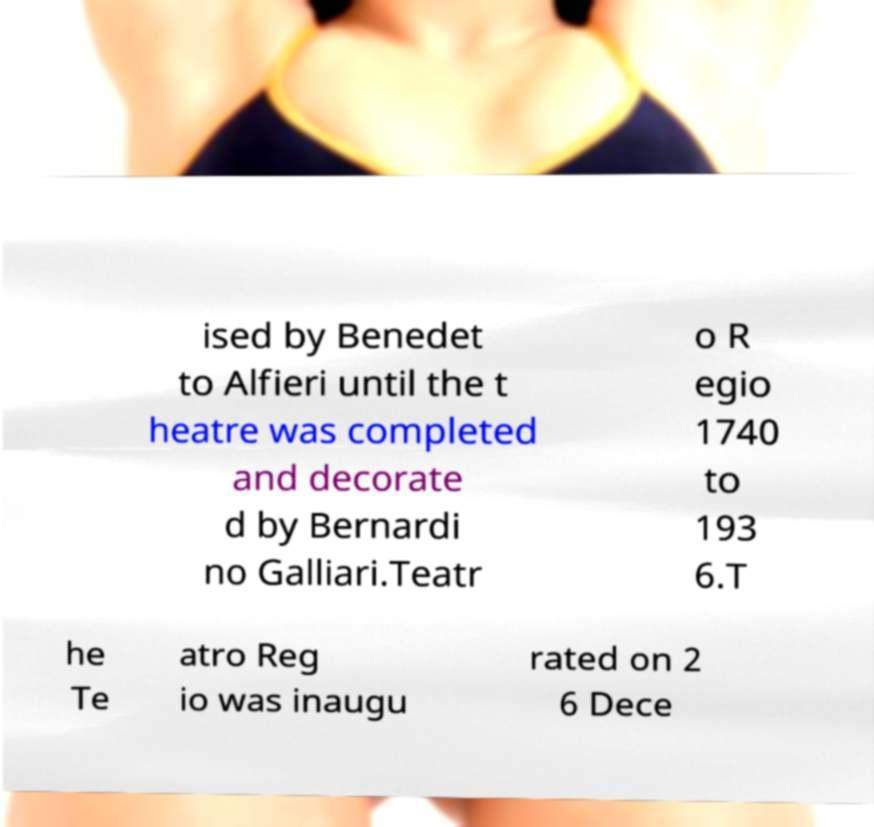There's text embedded in this image that I need extracted. Can you transcribe it verbatim? ised by Benedet to Alfieri until the t heatre was completed and decorate d by Bernardi no Galliari.Teatr o R egio 1740 to 193 6.T he Te atro Reg io was inaugu rated on 2 6 Dece 